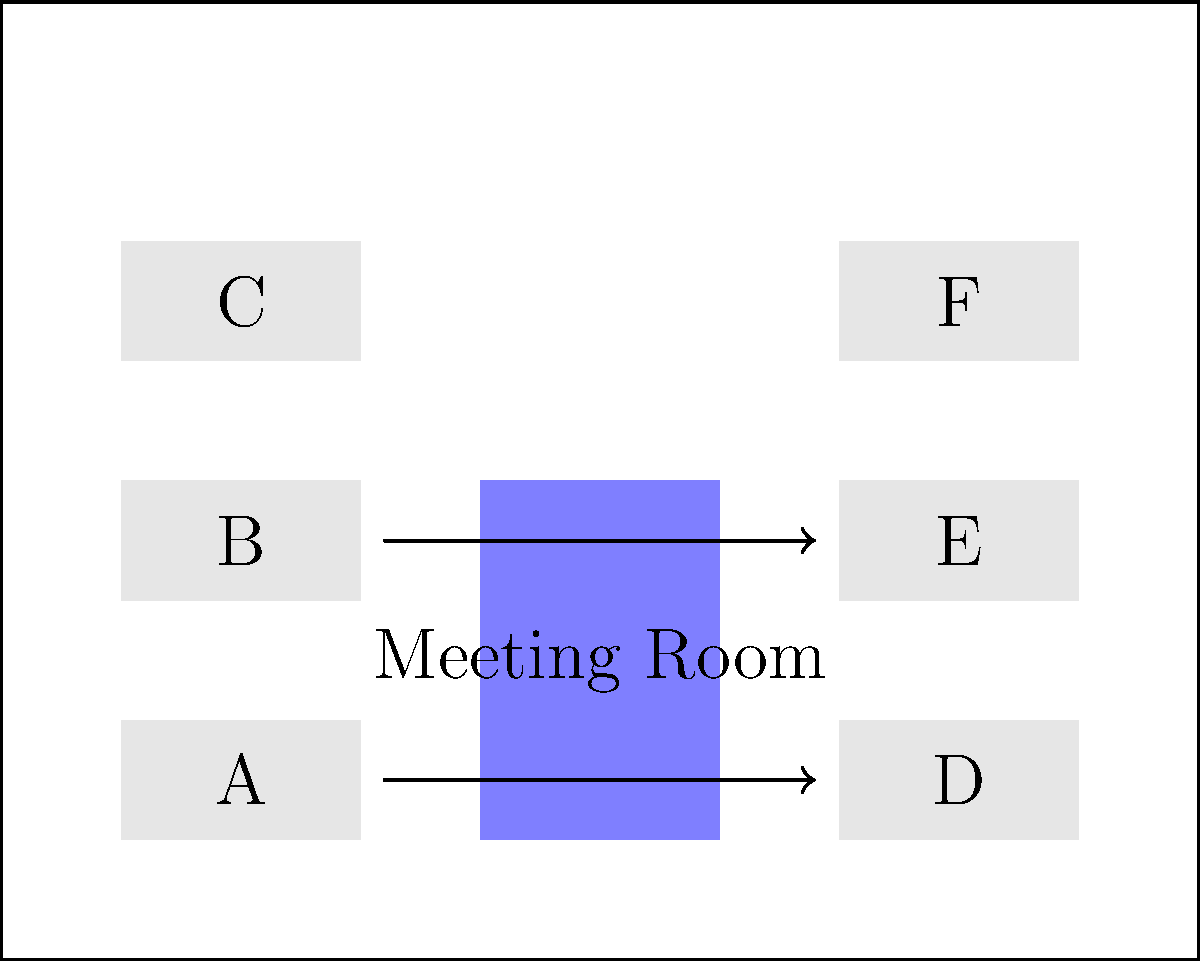In the given office floor plan, which desk arrangement would optimize collaboration between team members while maintaining a balance between quiet work areas and interactive spaces? Consider moving desks A and B to the right side of the office. To optimize the office layout for collaboration while maintaining a balance between quiet and interactive spaces, we should consider the following steps:

1. Analyze the current layout:
   - Six desks (A-F) are arranged in two columns of three on opposite sides of the office.
   - A meeting room is located in the center, separating the two desk columns.

2. Identify the optimization goals:
   - Improve collaboration between team members
   - Maintain a balance between quiet work areas and interactive spaces

3. Consider moving desks A and B:
   - Moving these desks to the right side will create a more open space on the left side of the office.
   - This can potentially increase interaction between team members.

4. Evaluate the impact of moving desks A and B:
   - Pros:
     a. Creates a larger open area on the left side, which can be used for impromptu discussions or small group collaborations.
     b. Brings more team members to the right side, potentially increasing interactions.
   - Cons:
     a. May reduce the number of quiet work areas.
     b. Could lead to increased noise levels on the right side of the office.

5. Propose an optimized layout:
   - Move desk A to the space between desks D and E.
   - Move desk B to the space between desks E and F.
   - Keep desk C in its original position to maintain some quiet work areas.

6. Assess the benefits of the new layout:
   - Improved collaboration: Five desks (A, B, D, E, F) are now in close proximity, facilitating easier communication and teamwork.
   - Balanced spaces: The left side of the office becomes an open collaborative area, while the right side offers a mix of interactive and focused work spaces.
   - Quiet area maintained: Desk C remains in its original position, providing a quieter work area for tasks requiring more concentration.

This arrangement optimizes collaboration by bringing more team members together on one side of the office while still maintaining a balance between interactive and quiet spaces.
Answer: Move desks A and B to the right side, between D-E and E-F respectively. 